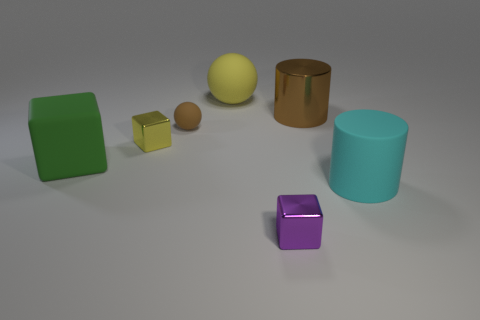Add 1 small brown matte balls. How many objects exist? 8 Subtract all spheres. How many objects are left? 5 Add 5 large yellow matte spheres. How many large yellow matte spheres are left? 6 Add 3 tiny blocks. How many tiny blocks exist? 5 Subtract 0 purple balls. How many objects are left? 7 Subtract all cyan objects. Subtract all big spheres. How many objects are left? 5 